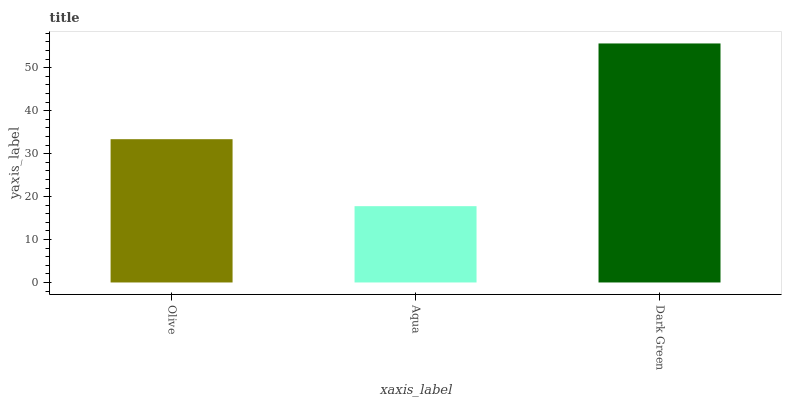Is Aqua the minimum?
Answer yes or no. Yes. Is Dark Green the maximum?
Answer yes or no. Yes. Is Dark Green the minimum?
Answer yes or no. No. Is Aqua the maximum?
Answer yes or no. No. Is Dark Green greater than Aqua?
Answer yes or no. Yes. Is Aqua less than Dark Green?
Answer yes or no. Yes. Is Aqua greater than Dark Green?
Answer yes or no. No. Is Dark Green less than Aqua?
Answer yes or no. No. Is Olive the high median?
Answer yes or no. Yes. Is Olive the low median?
Answer yes or no. Yes. Is Dark Green the high median?
Answer yes or no. No. Is Dark Green the low median?
Answer yes or no. No. 